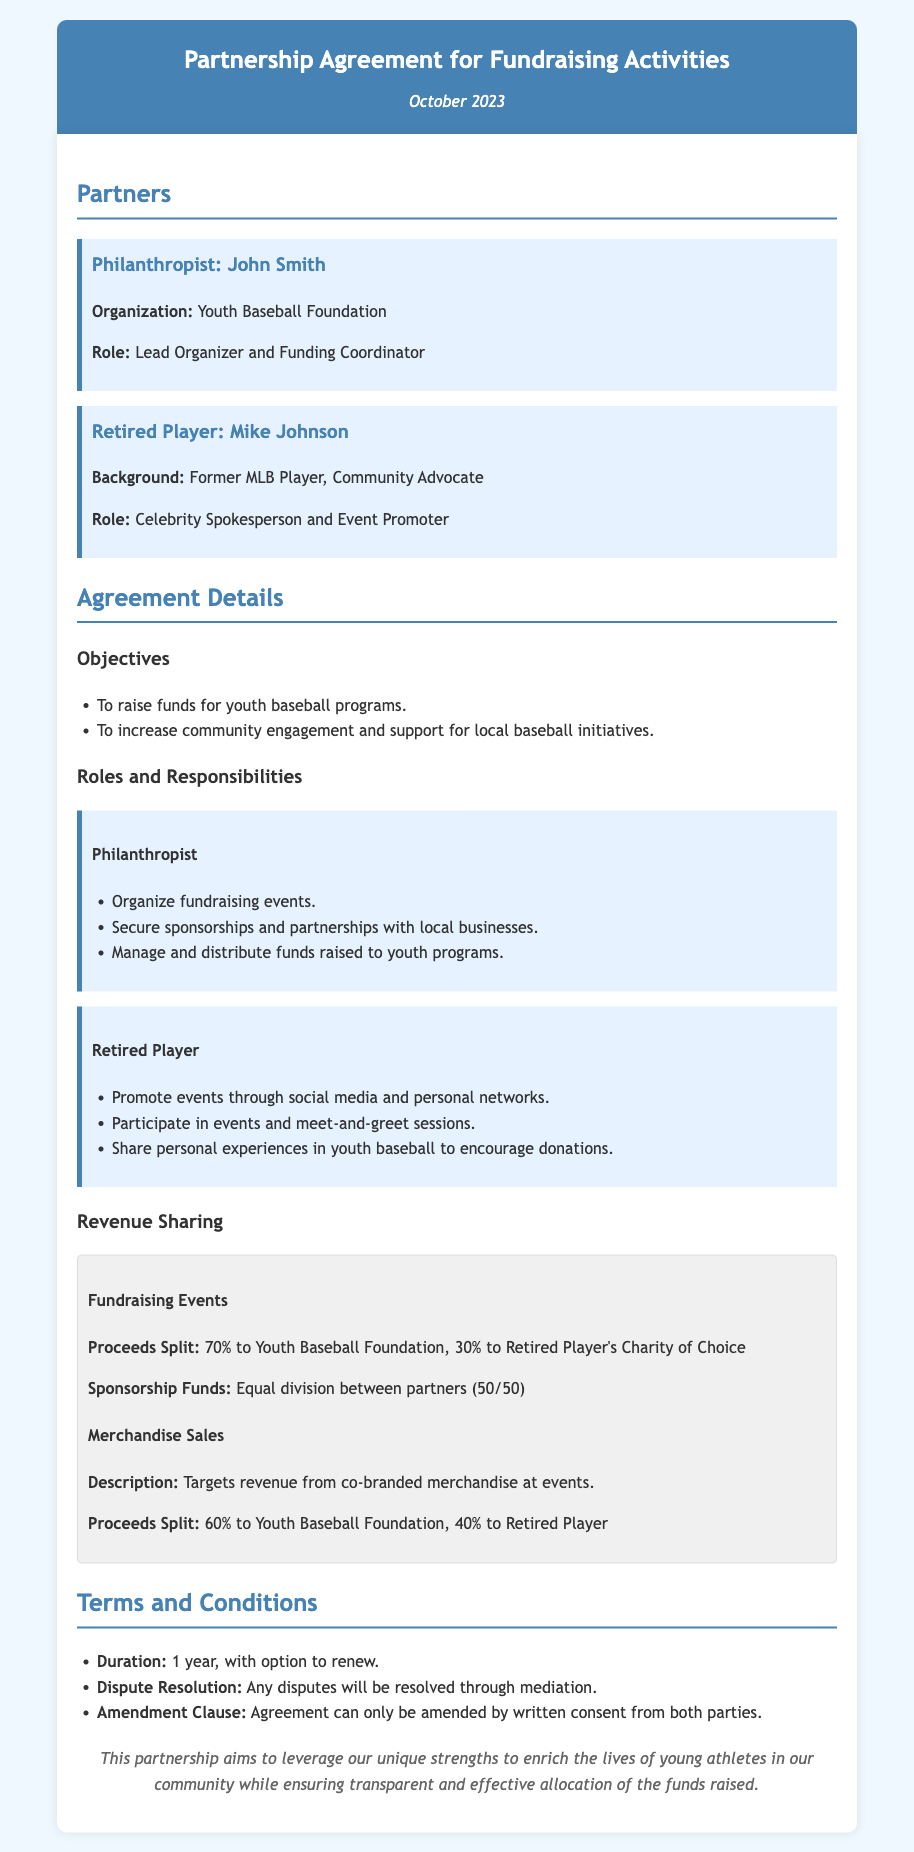What is the name of the philanthropist? The document states that the philanthropist is John Smith.
Answer: John Smith Who is the retired player involved in the partnership? The retired player mentioned in the document is Mike Johnson.
Answer: Mike Johnson What percentage of proceeds from fundraising events goes to the Youth Baseball Foundation? The document specifies that 70% of the proceeds from fundraising events go to the Youth Baseball Foundation.
Answer: 70% What is the duration of the agreement? According to the document, the duration of the agreement is 1 year, with an option to renew.
Answer: 1 year What is the sponsor funds division between the partners? The document mentions that sponsorship funds are divided equally between partners, which is 50/50.
Answer: 50/50 What role does the philanthropist play in the partnership? The document states that the philanthropist is the Lead Organizer and Funding Coordinator.
Answer: Lead Organizer and Funding Coordinator What is the proceeds split from merchandise sales? The document specifies that the proceeds from merchandise sales are split as 60% to the Youth Baseball Foundation and 40% to the retired player.
Answer: 60% to Youth Baseball Foundation, 40% to Retired Player How will disputes be resolved according to the agreement? The document states that any disputes will be resolved through mediation.
Answer: Mediation What is the retired player's role in the partnership? The document states that the retired player serves as the Celebrity Spokesperson and Event Promoter.
Answer: Celebrity Spokesperson and Event Promoter 